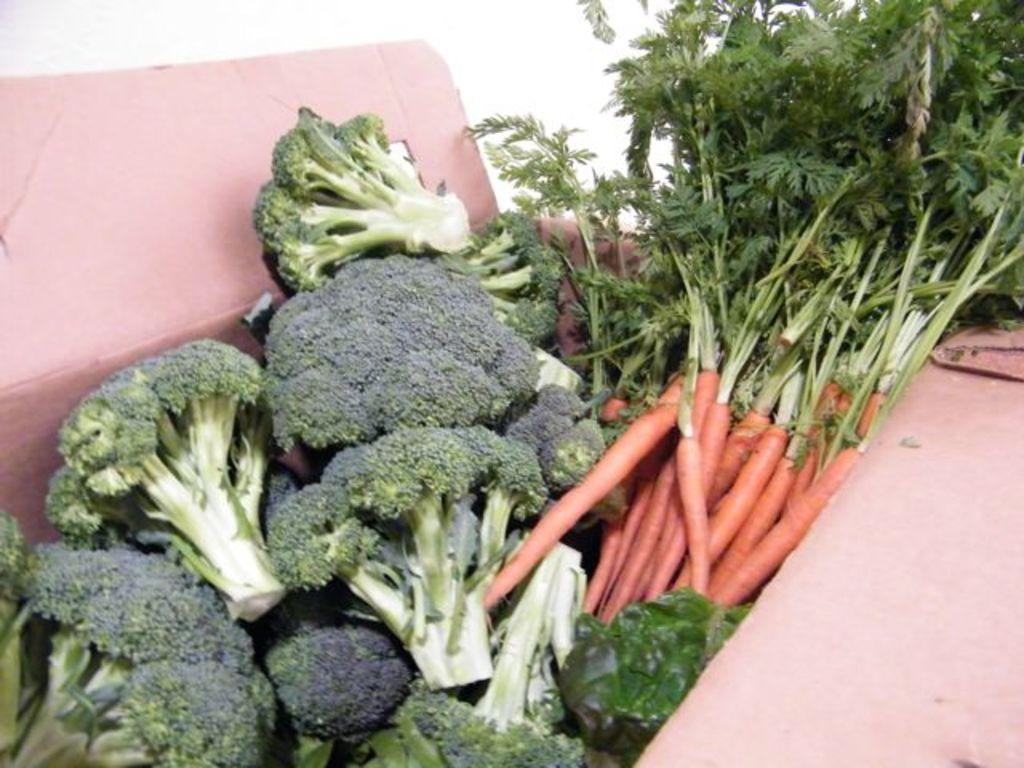Describe this image in one or two sentences. This image consists of raw vegetables in the carton box which is in the center. 